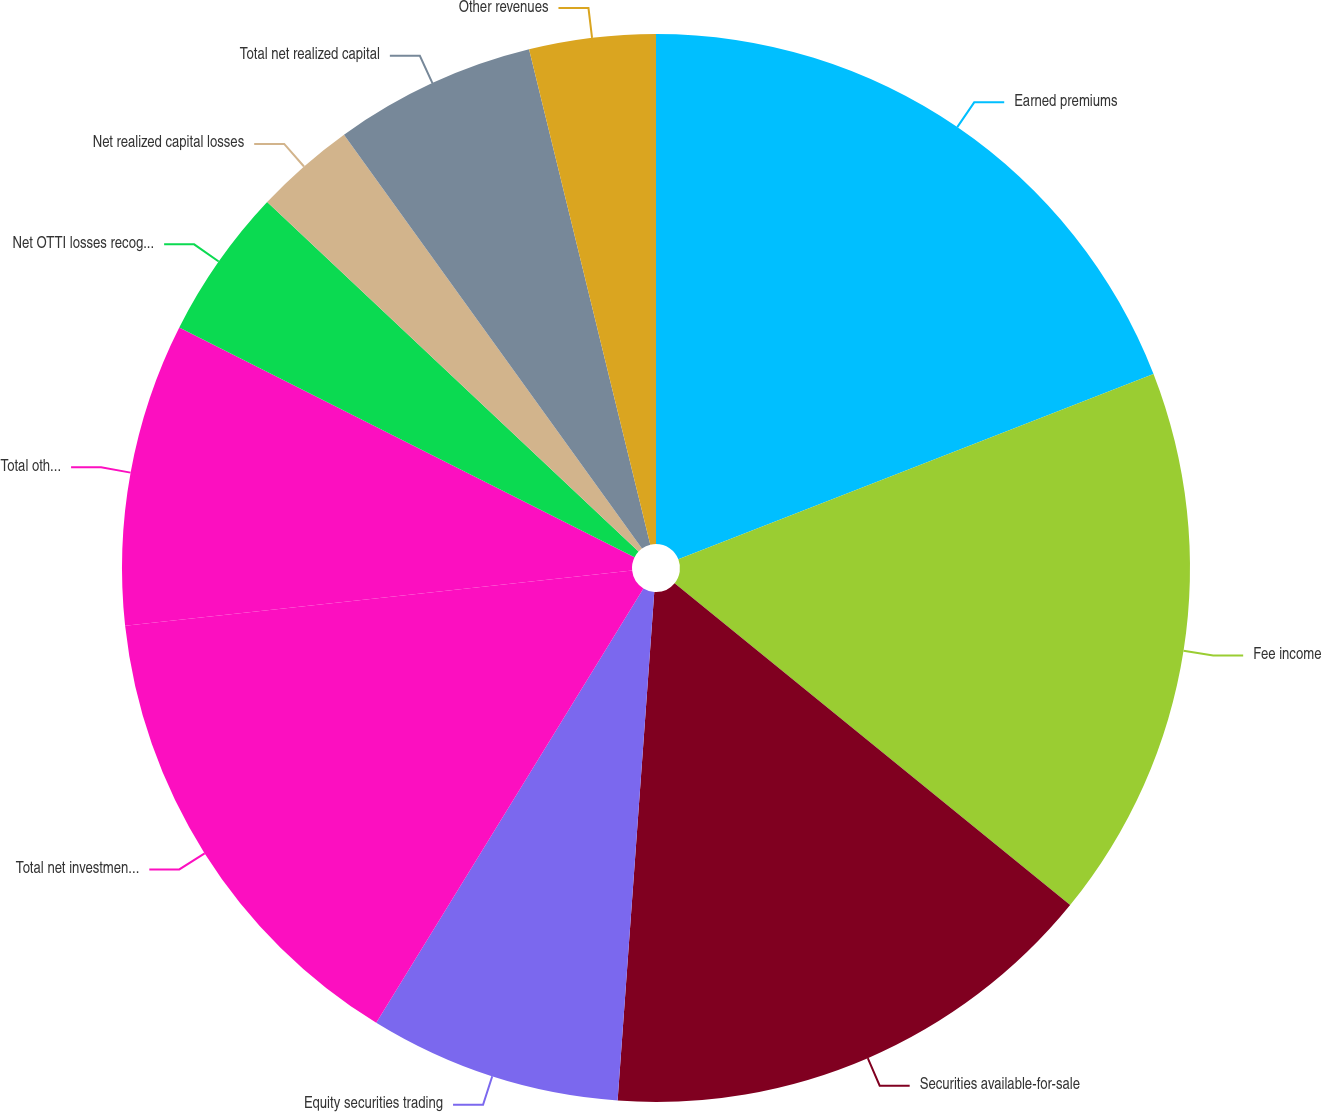Convert chart. <chart><loc_0><loc_0><loc_500><loc_500><pie_chart><fcel>Earned premiums<fcel>Fee income<fcel>Securities available-for-sale<fcel>Equity securities trading<fcel>Total net investment income<fcel>Total other-than-temporary<fcel>Net OTTI losses recognized in<fcel>Net realized capital losses<fcel>Total net realized capital<fcel>Other revenues<nl><fcel>19.08%<fcel>16.79%<fcel>15.27%<fcel>7.63%<fcel>14.5%<fcel>9.16%<fcel>4.58%<fcel>3.05%<fcel>6.11%<fcel>3.82%<nl></chart> 